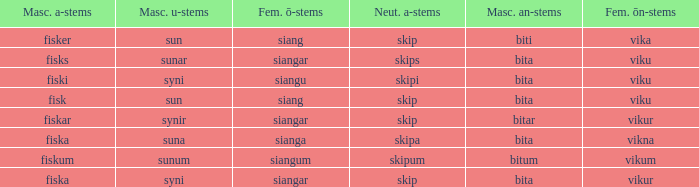What is the masculine an form for the word with a feminine ö ending of siangar and a masculine u ending of sunar? Bita. 